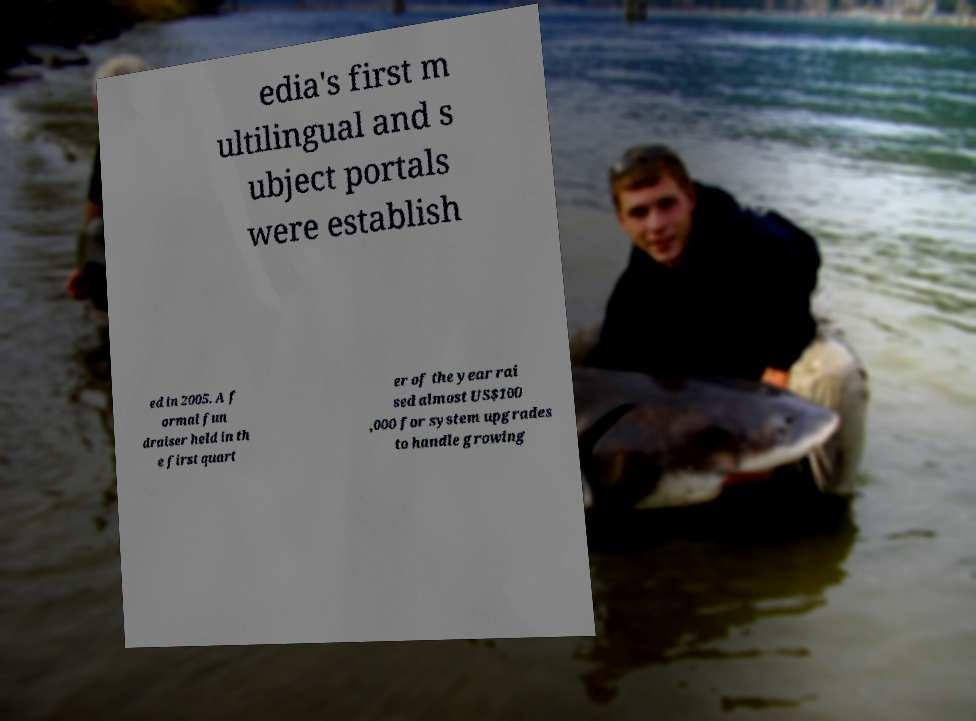Can you accurately transcribe the text from the provided image for me? edia's first m ultilingual and s ubject portals were establish ed in 2005. A f ormal fun draiser held in th e first quart er of the year rai sed almost US$100 ,000 for system upgrades to handle growing 